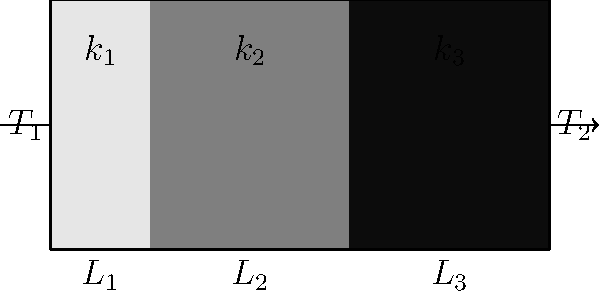A composite wall consists of three layers with thermal conductivities $k_1$, $k_2$, and $k_3$, and thicknesses $L_1$, $L_2$, and $L_3$, respectively. The temperatures on the outer surfaces are $T_1$ and $T_2$. What is the expression for the total heat transfer rate per unit area (heat flux) through this composite wall in steady-state conditions? To find the heat flux through the composite wall, we need to follow these steps:

1. Recall that for steady-state heat conduction, the heat flux is constant through all layers.

2. The heat flux through each layer can be expressed using Fourier's law of heat conduction:

   $q = -k \frac{dT}{dx}$

3. For a single layer with thickness $L$ and temperature difference $\Delta T$, this becomes:

   $q = k \frac{\Delta T}{L}$

4. In our composite wall, we have three layers in series. The total temperature difference is $(T_1 - T_2)$.

5. We can write the heat flux equation for each layer:

   Layer 1: $q = k_1 \frac{T_1 - T_a}{L_1}$
   Layer 2: $q = k_2 \frac{T_a - T_b}{L_2}$
   Layer 3: $q = k_3 \frac{T_b - T_2}{L_3}$

   Where $T_a$ and $T_b$ are the temperatures at the interfaces between layers.

6. Since the heat flux is constant, we can equate these:

   $q = k_1 \frac{T_1 - T_a}{L_1} = k_2 \frac{T_a - T_b}{L_2} = k_3 \frac{T_b - T_2}{L_3}$

7. The total temperature difference is the sum of the temperature differences across each layer:

   $T_1 - T_2 = (T_1 - T_a) + (T_a - T_b) + (T_b - T_2)$

8. We can express each temperature difference in terms of q:

   $T_1 - T_2 = \frac{qL_1}{k_1} + \frac{qL_2}{k_2} + \frac{qL_3}{k_3}$

9. Factoring out q:

   $T_1 - T_2 = q(\frac{L_1}{k_1} + \frac{L_2}{k_2} + \frac{L_3}{k_3})$

10. Solving for q:

    $q = \frac{T_1 - T_2}{\frac{L_1}{k_1} + \frac{L_2}{k_2} + \frac{L_3}{k_3}}$

This is the expression for the total heat flux through the composite wall.
Answer: $q = \frac{T_1 - T_2}{\frac{L_1}{k_1} + \frac{L_2}{k_2} + \frac{L_3}{k_3}}$ 